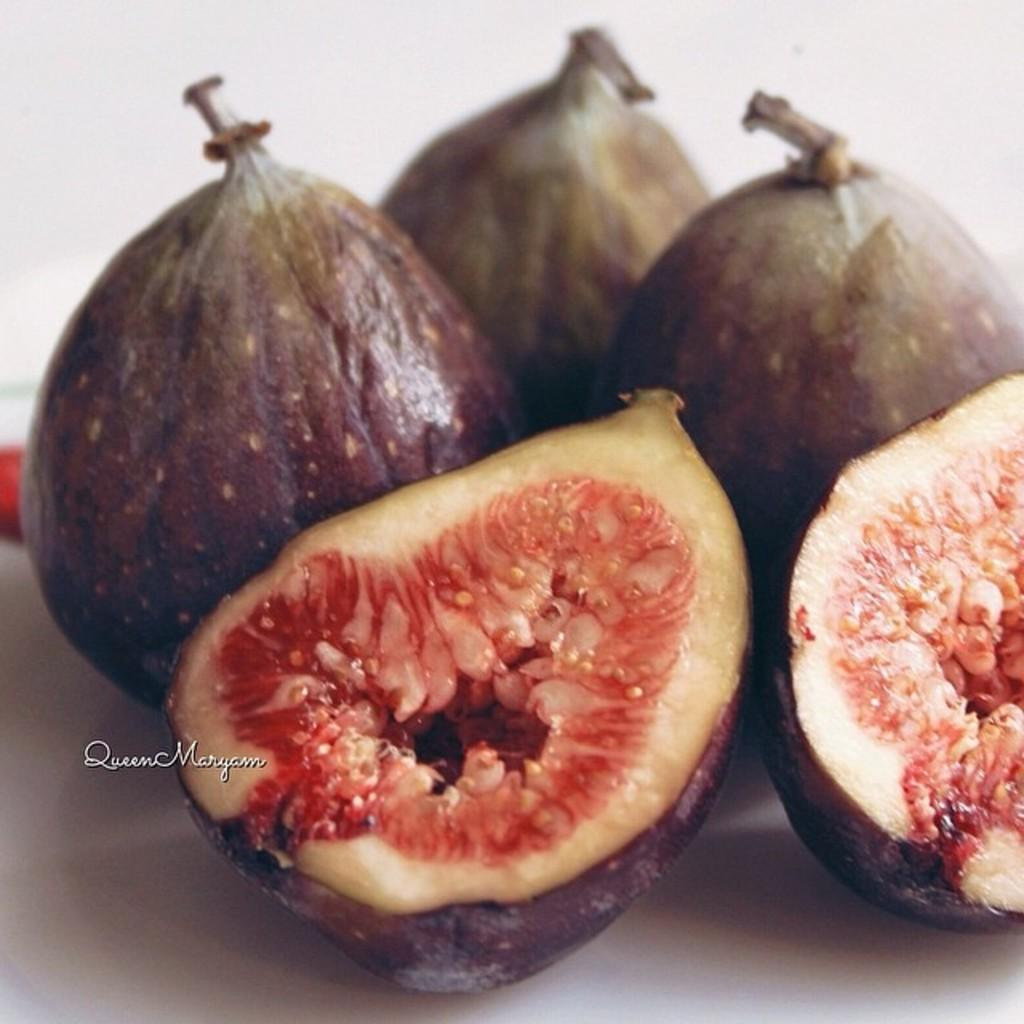What type of items can be seen in the image? The image contains food. What arithmetic problem is being solved on the plate in the image? There is no arithmetic problem present on the plate in the image. What part of the food is missing in the image? There is no indication of any missing part of the food in the image. 